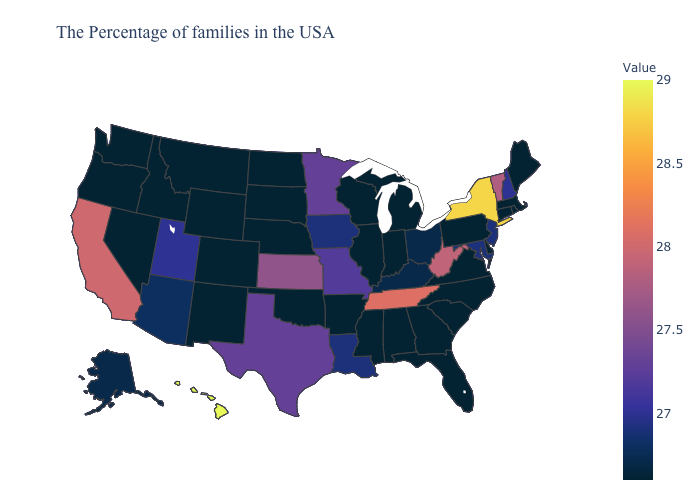Which states have the lowest value in the MidWest?
Keep it brief. Michigan, Indiana, Wisconsin, Illinois, Nebraska, South Dakota, North Dakota. Does Georgia have a higher value than New Jersey?
Quick response, please. No. Does Montana have the highest value in the West?
Write a very short answer. No. Does Hawaii have the highest value in the USA?
Short answer required. Yes. 